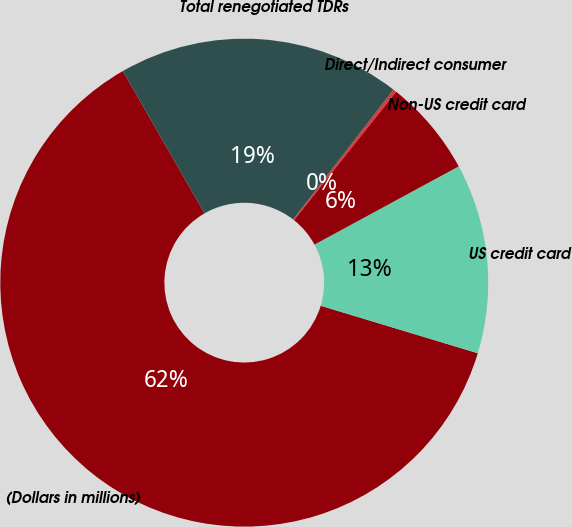Convert chart. <chart><loc_0><loc_0><loc_500><loc_500><pie_chart><fcel>(Dollars in millions)<fcel>US credit card<fcel>Non-US credit card<fcel>Direct/Indirect consumer<fcel>Total renegotiated TDRs<nl><fcel>62.04%<fcel>12.58%<fcel>6.4%<fcel>0.22%<fcel>18.76%<nl></chart> 